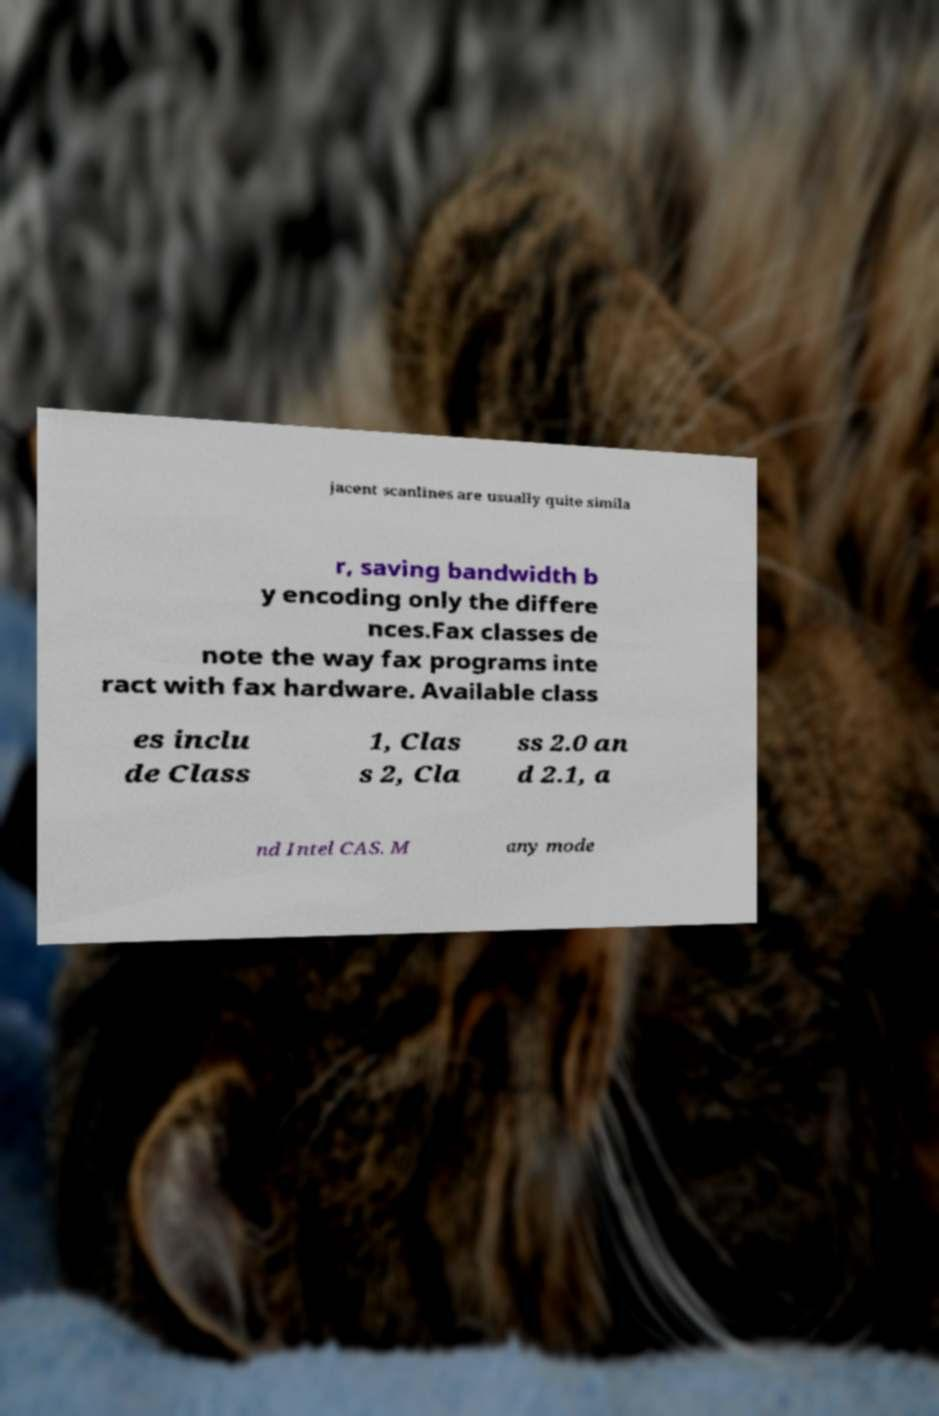Could you assist in decoding the text presented in this image and type it out clearly? jacent scanlines are usually quite simila r, saving bandwidth b y encoding only the differe nces.Fax classes de note the way fax programs inte ract with fax hardware. Available class es inclu de Class 1, Clas s 2, Cla ss 2.0 an d 2.1, a nd Intel CAS. M any mode 